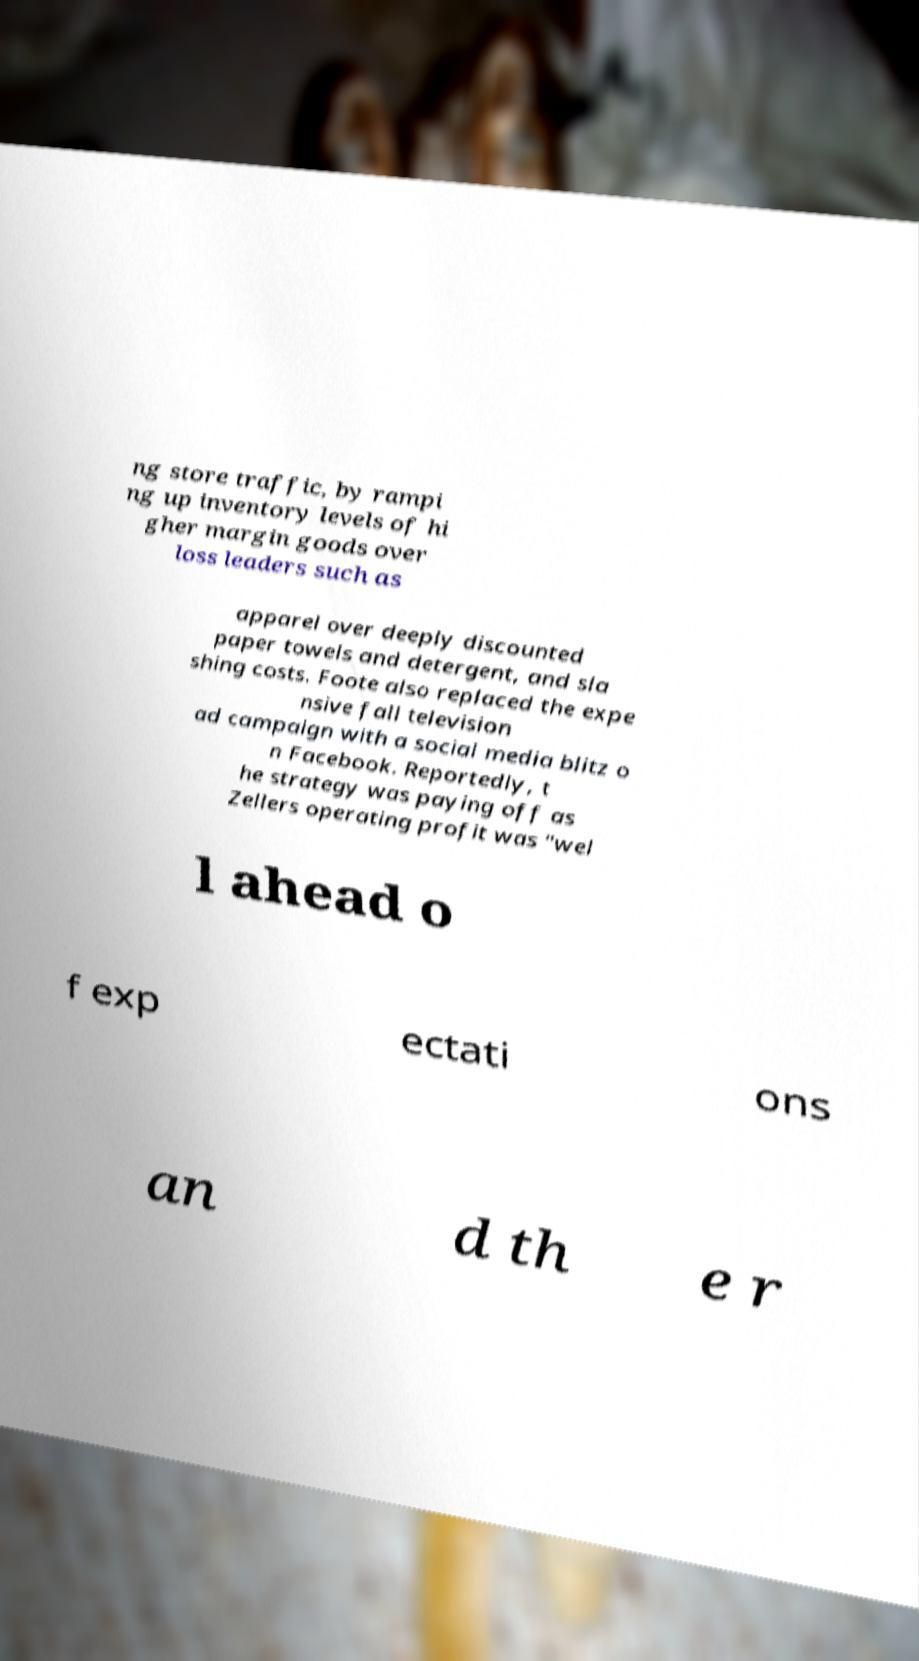I need the written content from this picture converted into text. Can you do that? ng store traffic, by rampi ng up inventory levels of hi gher margin goods over loss leaders such as apparel over deeply discounted paper towels and detergent, and sla shing costs. Foote also replaced the expe nsive fall television ad campaign with a social media blitz o n Facebook. Reportedly, t he strategy was paying off as Zellers operating profit was "wel l ahead o f exp ectati ons an d th e r 